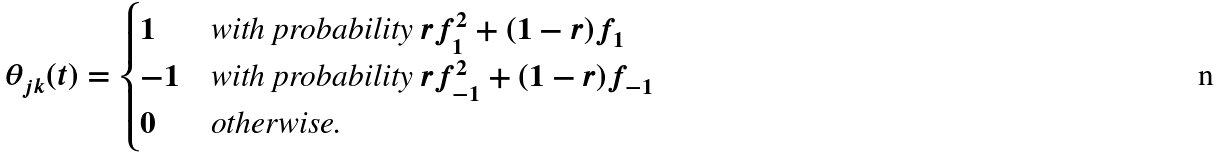<formula> <loc_0><loc_0><loc_500><loc_500>\theta _ { j k } ( t ) = \begin{cases} 1 & \text {with probability $rf_{1}^{2}+(1-r)f_{1}$} \\ - 1 & \text {with probability $rf_{-1}^{2}+(1-r)f_{-1}$} \\ 0 & \text {otherwise.} \end{cases}</formula> 